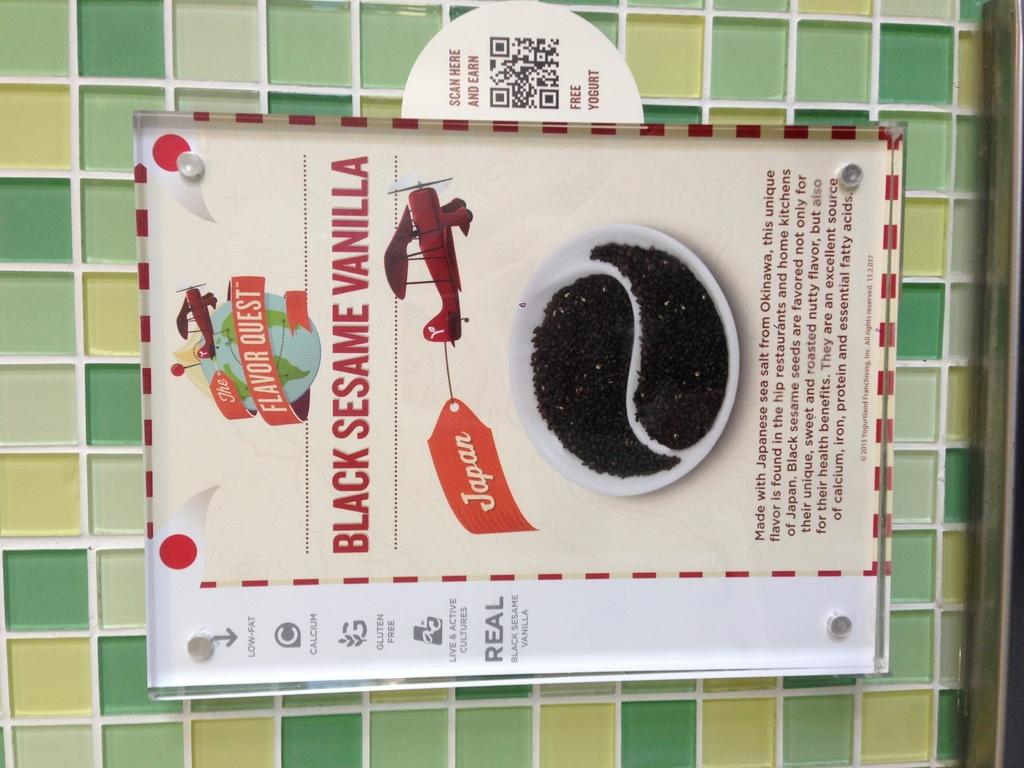<image>
Present a compact description of the photo's key features. An advertisement for black sesame vanilla coffee grounds. 